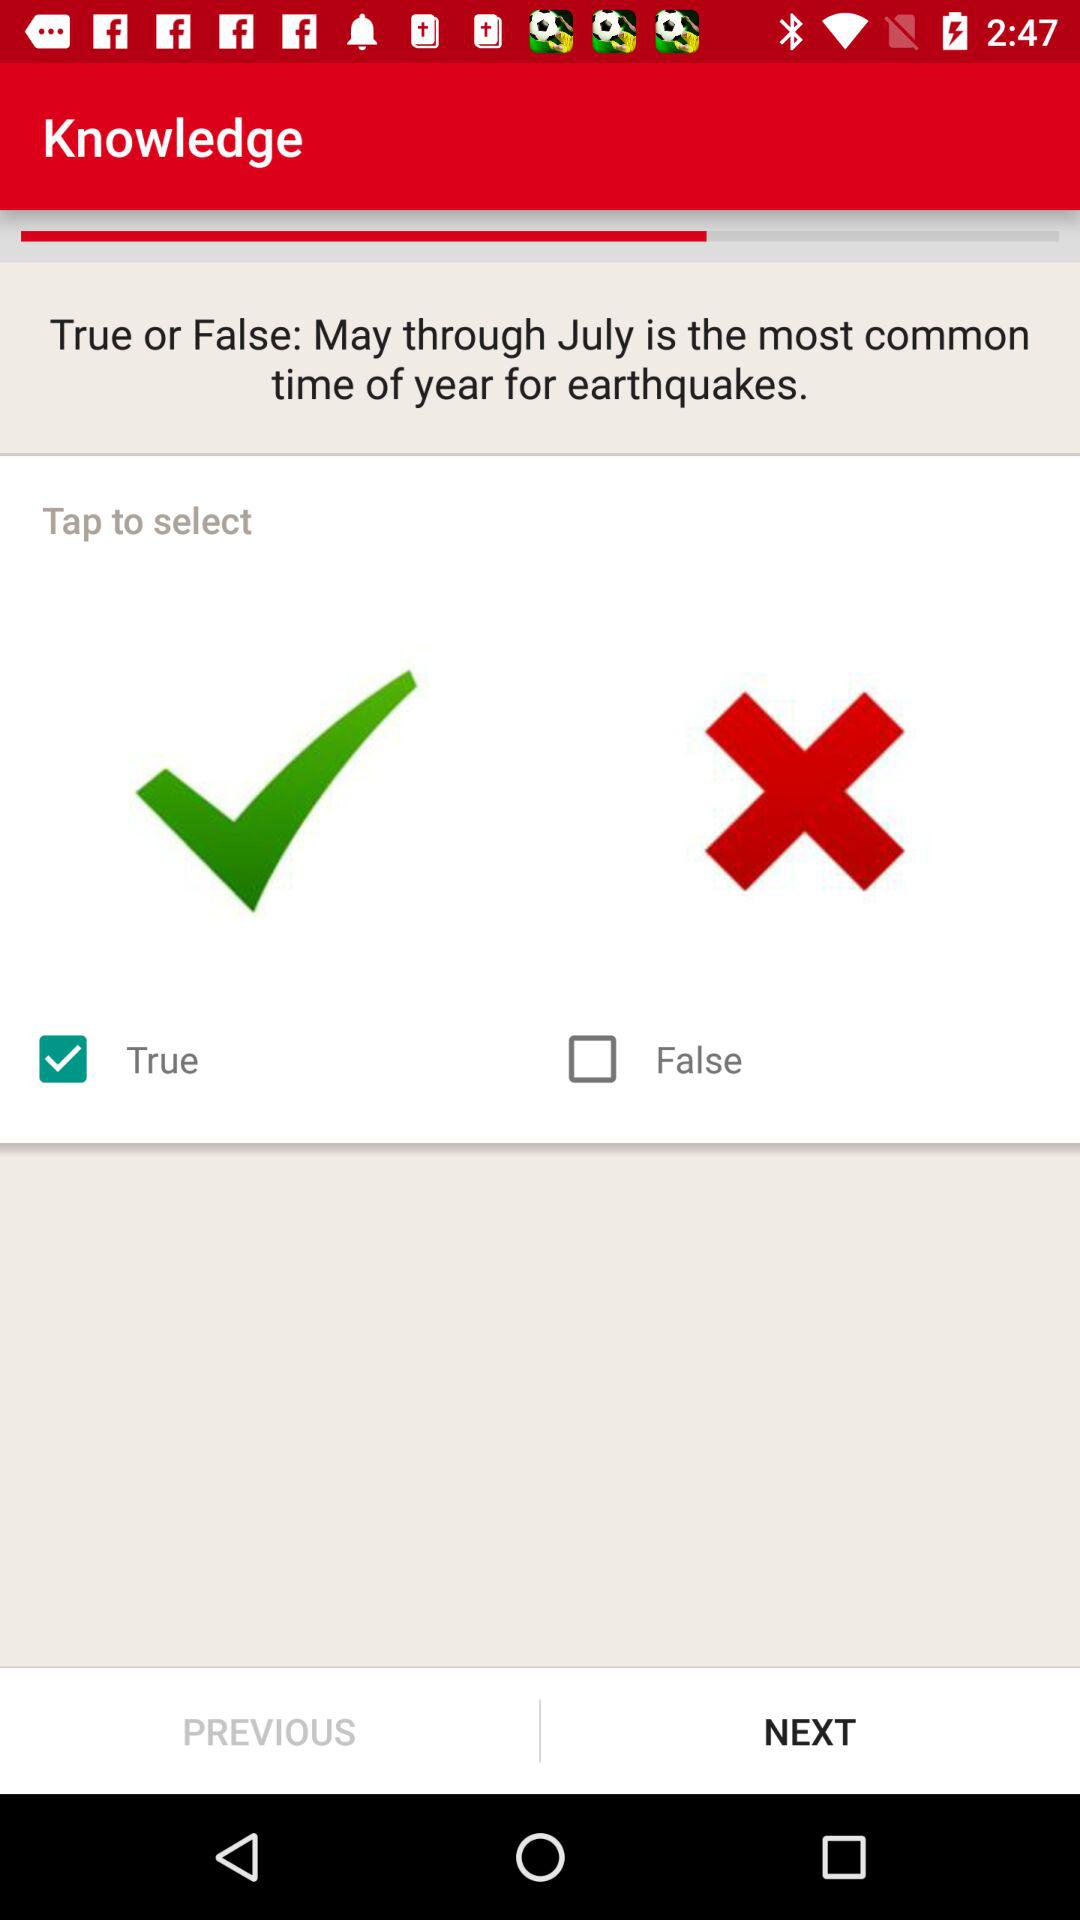How many checkmarks are there on the screen?
Answer the question using a single word or phrase. 1 